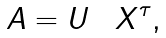Convert formula to latex. <formula><loc_0><loc_0><loc_500><loc_500>A = U \boldsymbol \Sigma X ^ { \tau } ,</formula> 